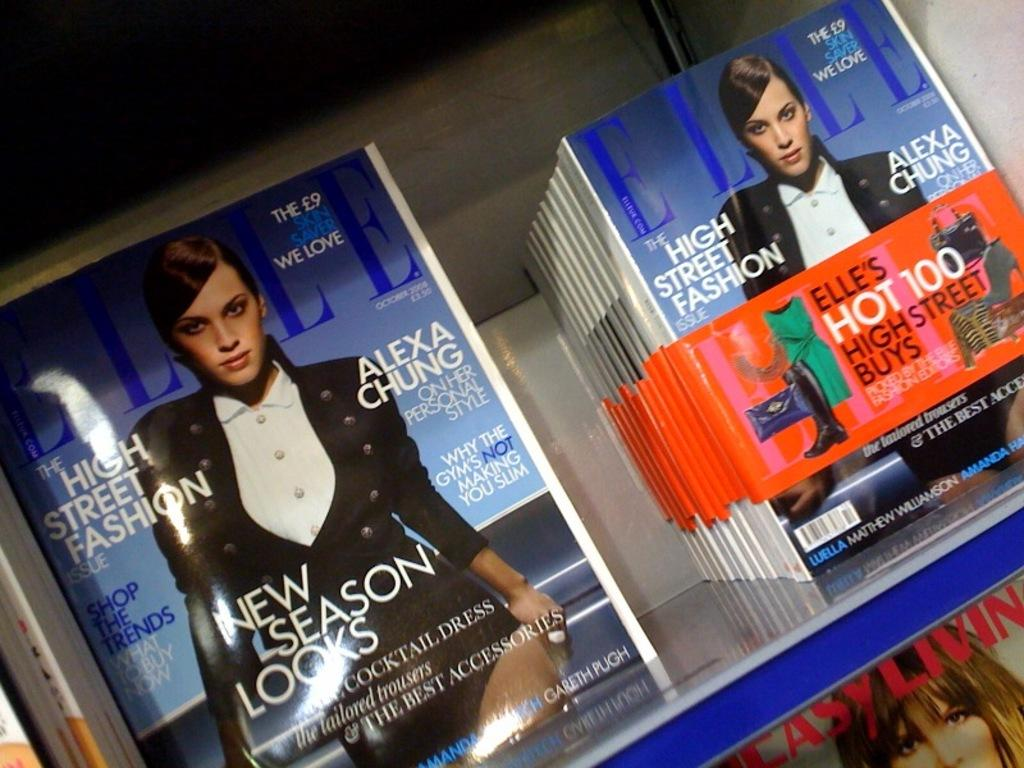<image>
Render a clear and concise summary of the photo. A bunch of Elle magazine on top of a grey table. 